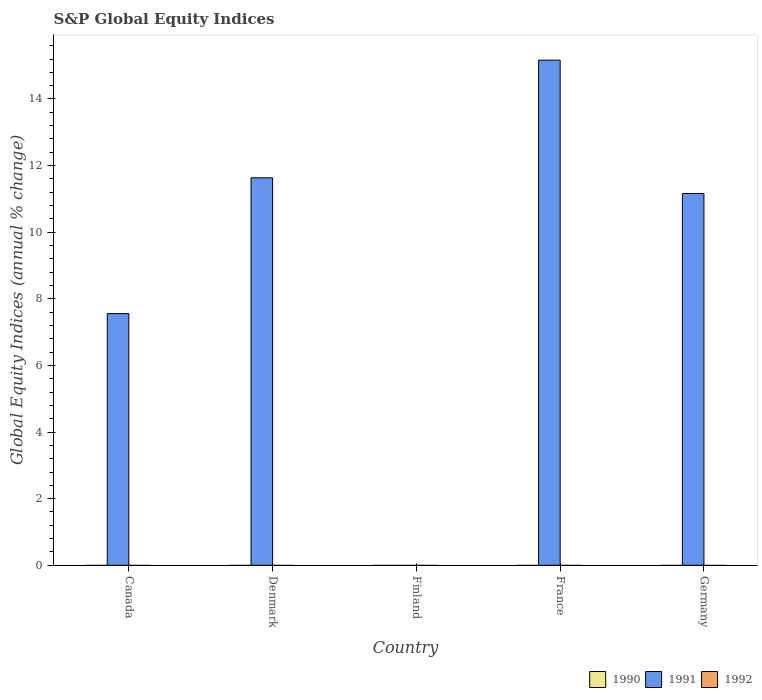How many different coloured bars are there?
Offer a very short reply. 1. Are the number of bars on each tick of the X-axis equal?
Give a very brief answer. No. How many bars are there on the 2nd tick from the left?
Provide a short and direct response. 1. How many bars are there on the 5th tick from the right?
Your response must be concise. 1. What is the global equity indices in 1992 in Denmark?
Keep it short and to the point. 0. Across all countries, what is the minimum global equity indices in 1992?
Provide a short and direct response. 0. What is the total global equity indices in 1991 in the graph?
Ensure brevity in your answer.  45.52. What is the difference between the highest and the second highest global equity indices in 1991?
Provide a succinct answer. -0.47. What is the difference between the highest and the lowest global equity indices in 1991?
Give a very brief answer. 15.17. In how many countries, is the global equity indices in 1992 greater than the average global equity indices in 1992 taken over all countries?
Provide a succinct answer. 0. Is the sum of the global equity indices in 1991 in Canada and France greater than the maximum global equity indices in 1992 across all countries?
Offer a terse response. Yes. Is it the case that in every country, the sum of the global equity indices in 1990 and global equity indices in 1991 is greater than the global equity indices in 1992?
Your answer should be compact. No. What is the difference between two consecutive major ticks on the Y-axis?
Provide a succinct answer. 2. Where does the legend appear in the graph?
Make the answer very short. Bottom right. What is the title of the graph?
Keep it short and to the point. S&P Global Equity Indices. Does "1984" appear as one of the legend labels in the graph?
Ensure brevity in your answer.  No. What is the label or title of the Y-axis?
Ensure brevity in your answer.  Global Equity Indices (annual % change). What is the Global Equity Indices (annual % change) of 1990 in Canada?
Provide a short and direct response. 0. What is the Global Equity Indices (annual % change) of 1991 in Canada?
Ensure brevity in your answer.  7.56. What is the Global Equity Indices (annual % change) in 1990 in Denmark?
Ensure brevity in your answer.  0. What is the Global Equity Indices (annual % change) of 1991 in Denmark?
Make the answer very short. 11.63. What is the Global Equity Indices (annual % change) in 1990 in France?
Your answer should be very brief. 0. What is the Global Equity Indices (annual % change) of 1991 in France?
Your answer should be compact. 15.17. What is the Global Equity Indices (annual % change) in 1992 in France?
Provide a short and direct response. 0. What is the Global Equity Indices (annual % change) of 1990 in Germany?
Offer a very short reply. 0. What is the Global Equity Indices (annual % change) of 1991 in Germany?
Give a very brief answer. 11.16. Across all countries, what is the maximum Global Equity Indices (annual % change) in 1991?
Offer a terse response. 15.17. Across all countries, what is the minimum Global Equity Indices (annual % change) in 1991?
Your response must be concise. 0. What is the total Global Equity Indices (annual % change) of 1991 in the graph?
Offer a terse response. 45.52. What is the total Global Equity Indices (annual % change) of 1992 in the graph?
Your answer should be compact. 0. What is the difference between the Global Equity Indices (annual % change) in 1991 in Canada and that in Denmark?
Keep it short and to the point. -4.08. What is the difference between the Global Equity Indices (annual % change) in 1991 in Canada and that in France?
Offer a very short reply. -7.61. What is the difference between the Global Equity Indices (annual % change) in 1991 in Canada and that in Germany?
Provide a short and direct response. -3.61. What is the difference between the Global Equity Indices (annual % change) in 1991 in Denmark and that in France?
Provide a short and direct response. -3.53. What is the difference between the Global Equity Indices (annual % change) in 1991 in Denmark and that in Germany?
Provide a short and direct response. 0.47. What is the difference between the Global Equity Indices (annual % change) of 1991 in France and that in Germany?
Offer a very short reply. 4. What is the average Global Equity Indices (annual % change) of 1991 per country?
Keep it short and to the point. 9.1. What is the ratio of the Global Equity Indices (annual % change) of 1991 in Canada to that in Denmark?
Ensure brevity in your answer.  0.65. What is the ratio of the Global Equity Indices (annual % change) of 1991 in Canada to that in France?
Your response must be concise. 0.5. What is the ratio of the Global Equity Indices (annual % change) in 1991 in Canada to that in Germany?
Provide a succinct answer. 0.68. What is the ratio of the Global Equity Indices (annual % change) in 1991 in Denmark to that in France?
Give a very brief answer. 0.77. What is the ratio of the Global Equity Indices (annual % change) of 1991 in Denmark to that in Germany?
Your answer should be very brief. 1.04. What is the ratio of the Global Equity Indices (annual % change) of 1991 in France to that in Germany?
Your answer should be very brief. 1.36. What is the difference between the highest and the second highest Global Equity Indices (annual % change) in 1991?
Make the answer very short. 3.53. What is the difference between the highest and the lowest Global Equity Indices (annual % change) of 1991?
Make the answer very short. 15.17. 